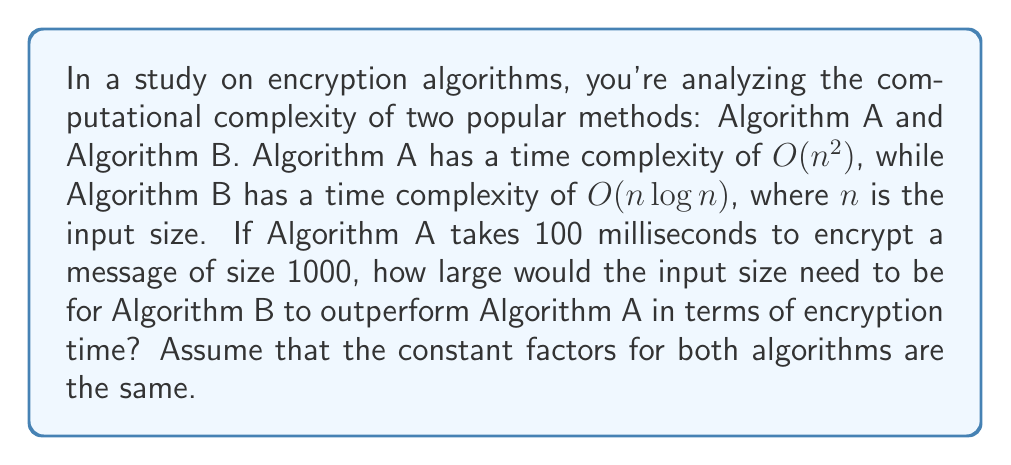Show me your answer to this math problem. To solve this problem, we need to follow these steps:

1) First, let's establish the relationship between the input size and time for Algorithm A:
   $$T_A(n) = k \cdot n^2$$
   where $k$ is some constant.

2) We know that for $n = 1000$, $T_A(1000) = 100$ ms. So:
   $$100 = k \cdot 1000^2$$
   $$k = \frac{100}{1000000} = 10^{-4}$$

3) Now, we can express the time complexity for Algorithm A as:
   $$T_A(n) = 10^{-4} \cdot n^2$$

4) For Algorithm B, the time complexity is:
   $$T_B(n) = 10^{-4} \cdot n \log n$$

5) To find when Algorithm B outperforms Algorithm A, we need to solve:
   $$10^{-4} \cdot n \log n < 10^{-4} \cdot n^2$$

6) Simplifying:
   $$n \log n < n^2$$
   $$\log n < n$$

7) This inequality is true for $n > e \approx 2.718$. However, we need to find a more practical value where the difference becomes significant.

8) We can solve this numerically using the bisection method:

   Let's start with $a = 1000$ and $b = 10000$:

   Iteration 1: $n = 5500$, $5500 \log 5500 \approx 48125 < 30250000 = 5500^2$
   Iteration 2: $n = 7750$, $7750 \log 7750 \approx 73562 < 60062500 = 7750^2$
   Iteration 3: $n = 8875$, $8875 \log 8875 \approx 88750 < 78765625 = 8875^2$
   Iteration 4: $n = 9437$, $9437 \log 9437 \approx 97607 > 89057969 = 9437^2$

9) We find that Algorithm B outperforms Algorithm A when $n$ is approximately 9437.
Answer: Algorithm B will outperform Algorithm A when the input size is approximately 9437. 